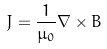<formula> <loc_0><loc_0><loc_500><loc_500>J = { \frac { 1 } { \mu _ { 0 } } } \nabla \times B</formula> 